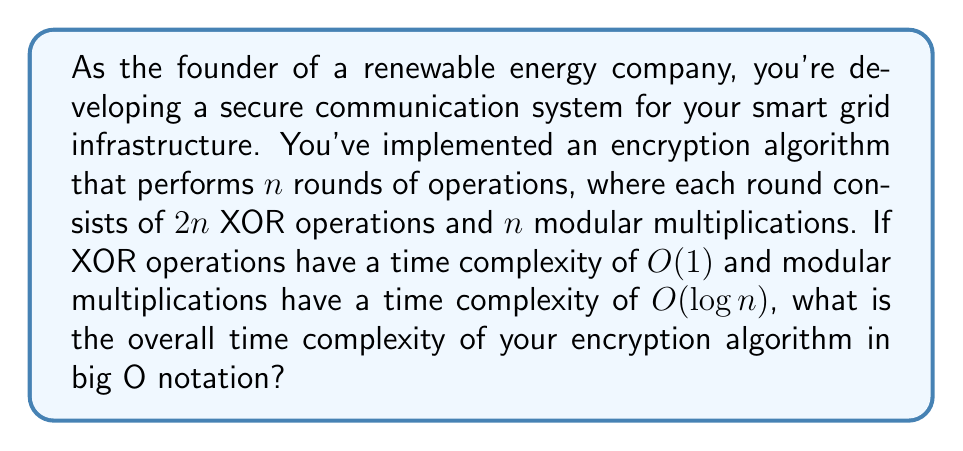Teach me how to tackle this problem. Let's break down the problem and analyze the time complexity step by step:

1. Number of rounds: $n$

2. Operations per round:
   - XOR operations: $2n$
   - Modular multiplications: $n$

3. Time complexity of each operation:
   - XOR: $O(1)$
   - Modular multiplication: $O(\log n)$

4. Time complexity for XOR operations per round:
   $O(2n \cdot 1) = O(n)$

5. Time complexity for modular multiplications per round:
   $O(n \cdot \log n) = O(n \log n)$

6. Total time complexity per round:
   $O(n) + O(n \log n) = O(n \log n)$

7. Overall time complexity for $n$ rounds:
   $O(n \cdot n \log n) = O(n^2 \log n)$

The dominant term in the time complexity is $O(n^2 \log n)$, which represents the overall time complexity of the encryption algorithm.
Answer: $O(n^2 \log n)$ 